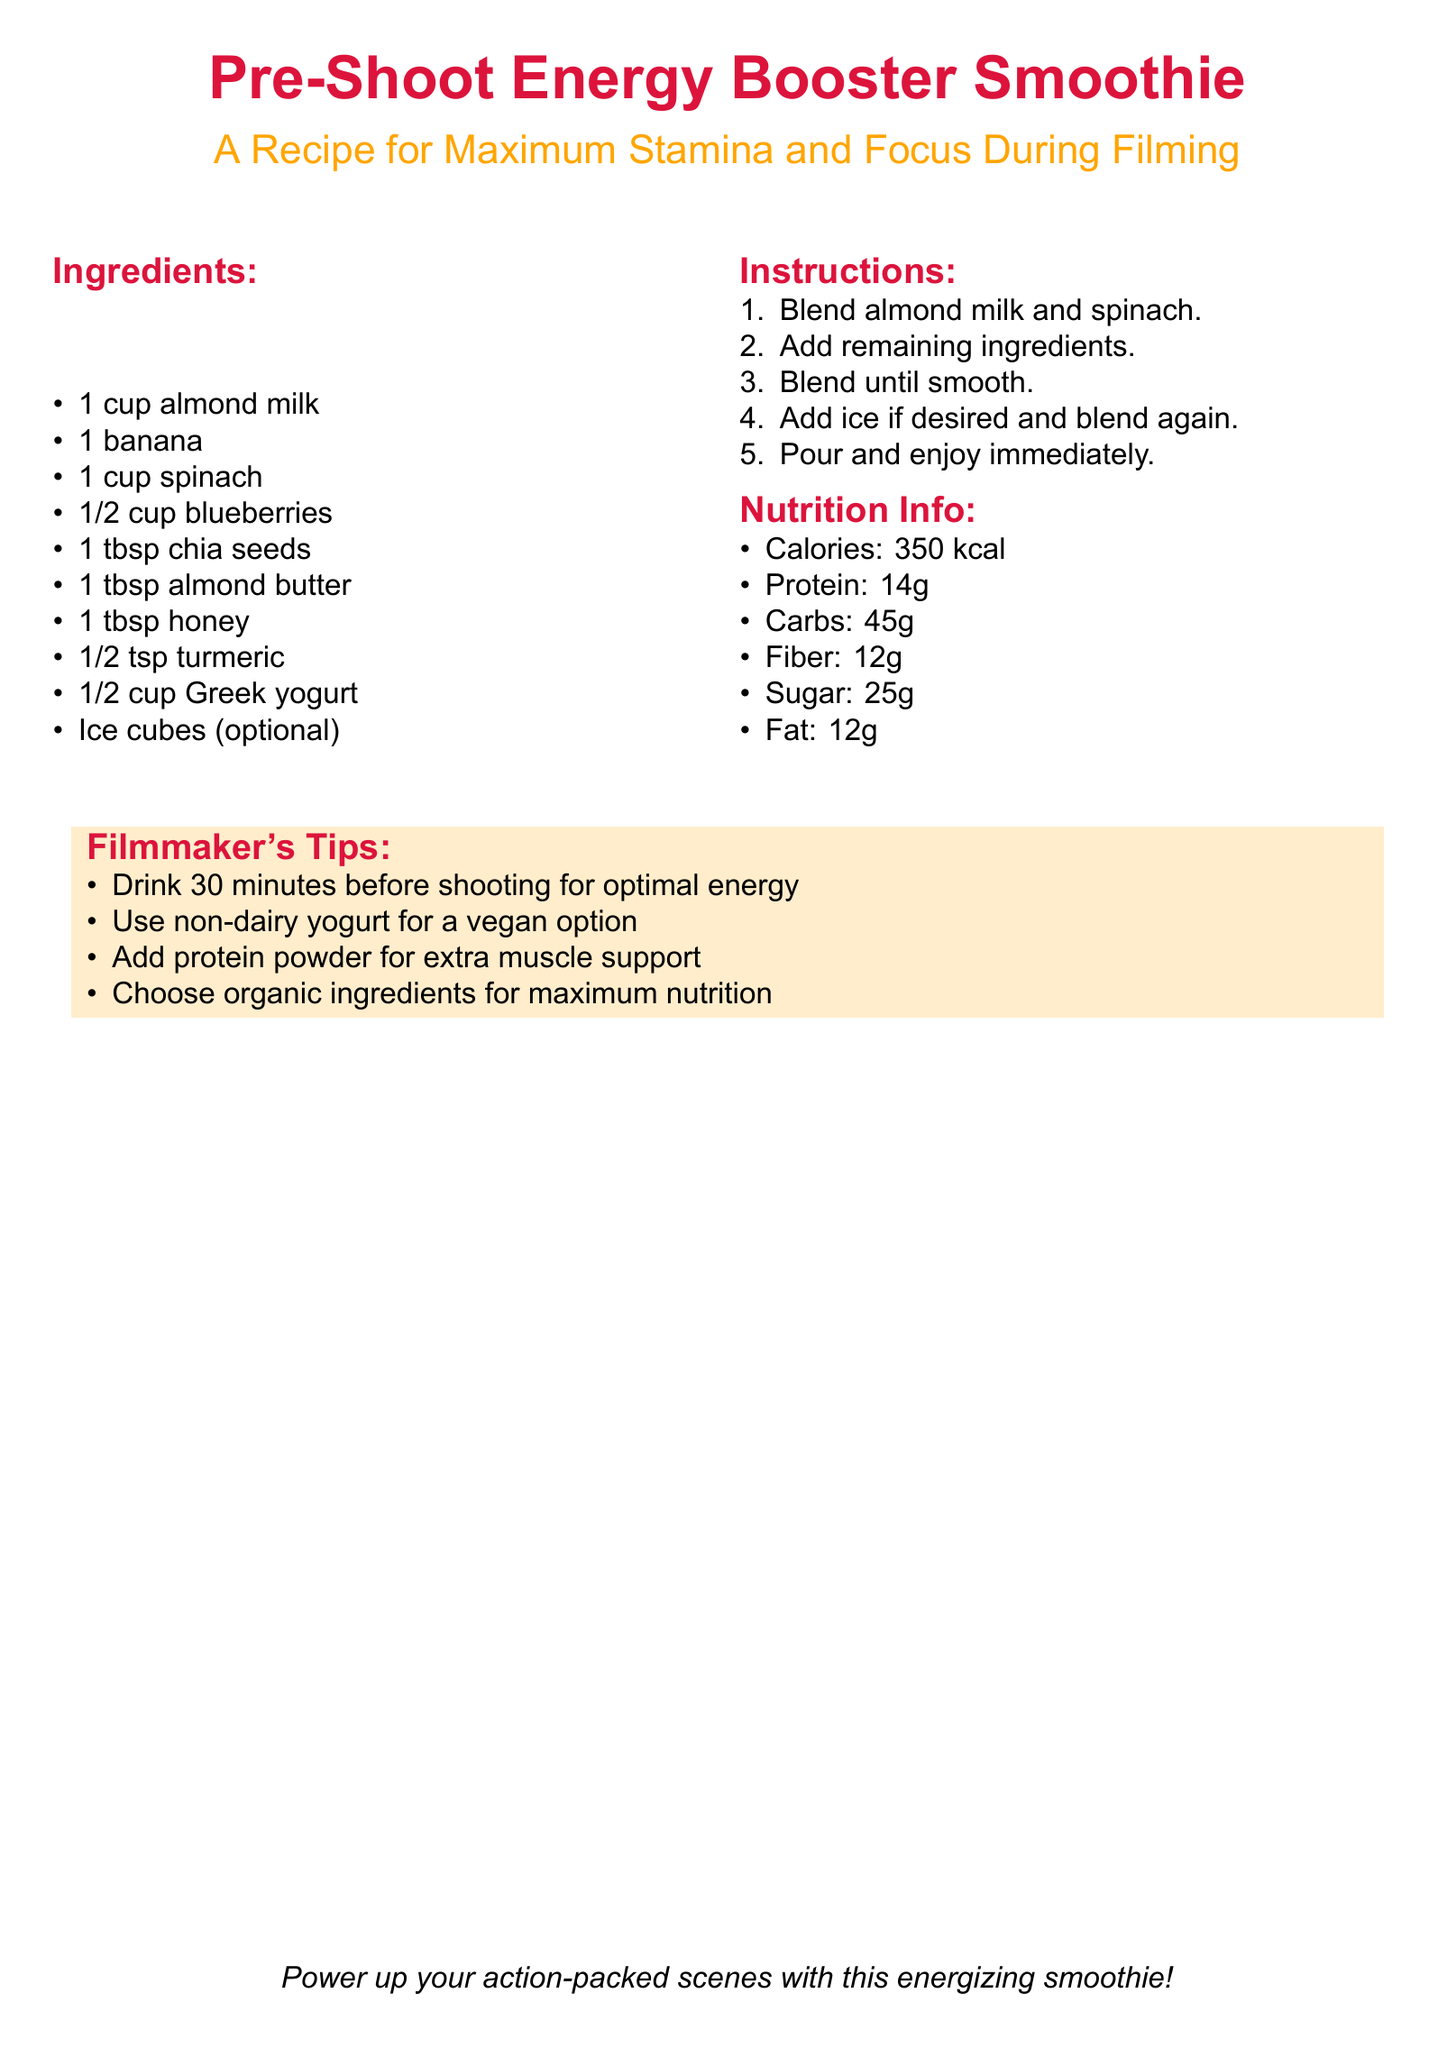What is the main title of the recipe? The main title of the recipe is located at the top of the document.
Answer: Pre-Shoot Energy Booster Smoothie How many calories does the smoothie have? The calorie count is stated in the nutrition info section of the document.
Answer: 350 kcal What type of milk is used in the recipe? The type of milk is specified in the ingredients list of the document.
Answer: Almond milk How much spinach is required for the smoothie? The amount of spinach is detailed in the ingredients list.
Answer: 1 cup What ingredient can be added for extra muscle support? The option for extra muscle support is mentioned in the filmmaker's tips section.
Answer: Protein powder How long before filming should the smoothie be consumed? This timing is provided in the filmmaker's tips for optimal energy.
Answer: 30 minutes What is one alternative suggested for a vegan option? The alternative is detailed in the filmmaker's tips for ingredient options.
Answer: Non-dairy yogurt How many tablespoons of chia seeds are in the recipe? The quantity of chia seeds is listed in the ingredients section.
Answer: 1 tbsp What is the color theme emphasized throughout the document? The color theme can be inferred from the title and headings colors used.
Answer: Red and orange 